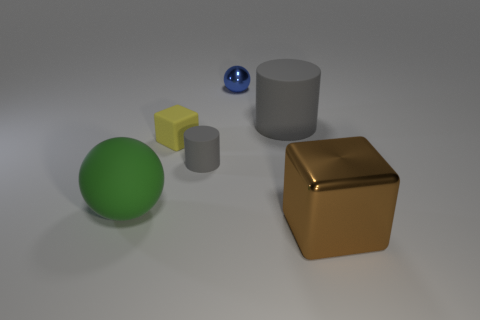Add 2 brown metallic objects. How many objects exist? 8 Subtract all cubes. How many objects are left? 4 Subtract 0 brown cylinders. How many objects are left? 6 Subtract all large green metal objects. Subtract all big brown metallic blocks. How many objects are left? 5 Add 3 yellow rubber things. How many yellow rubber things are left? 4 Add 5 tiny cylinders. How many tiny cylinders exist? 6 